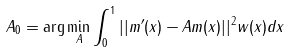Convert formula to latex. <formula><loc_0><loc_0><loc_500><loc_500>A _ { 0 } = \arg \min _ { A } \int _ { 0 } ^ { 1 } | | m ^ { \prime } ( x ) - A m ( x ) | | ^ { 2 } w ( x ) d x</formula> 